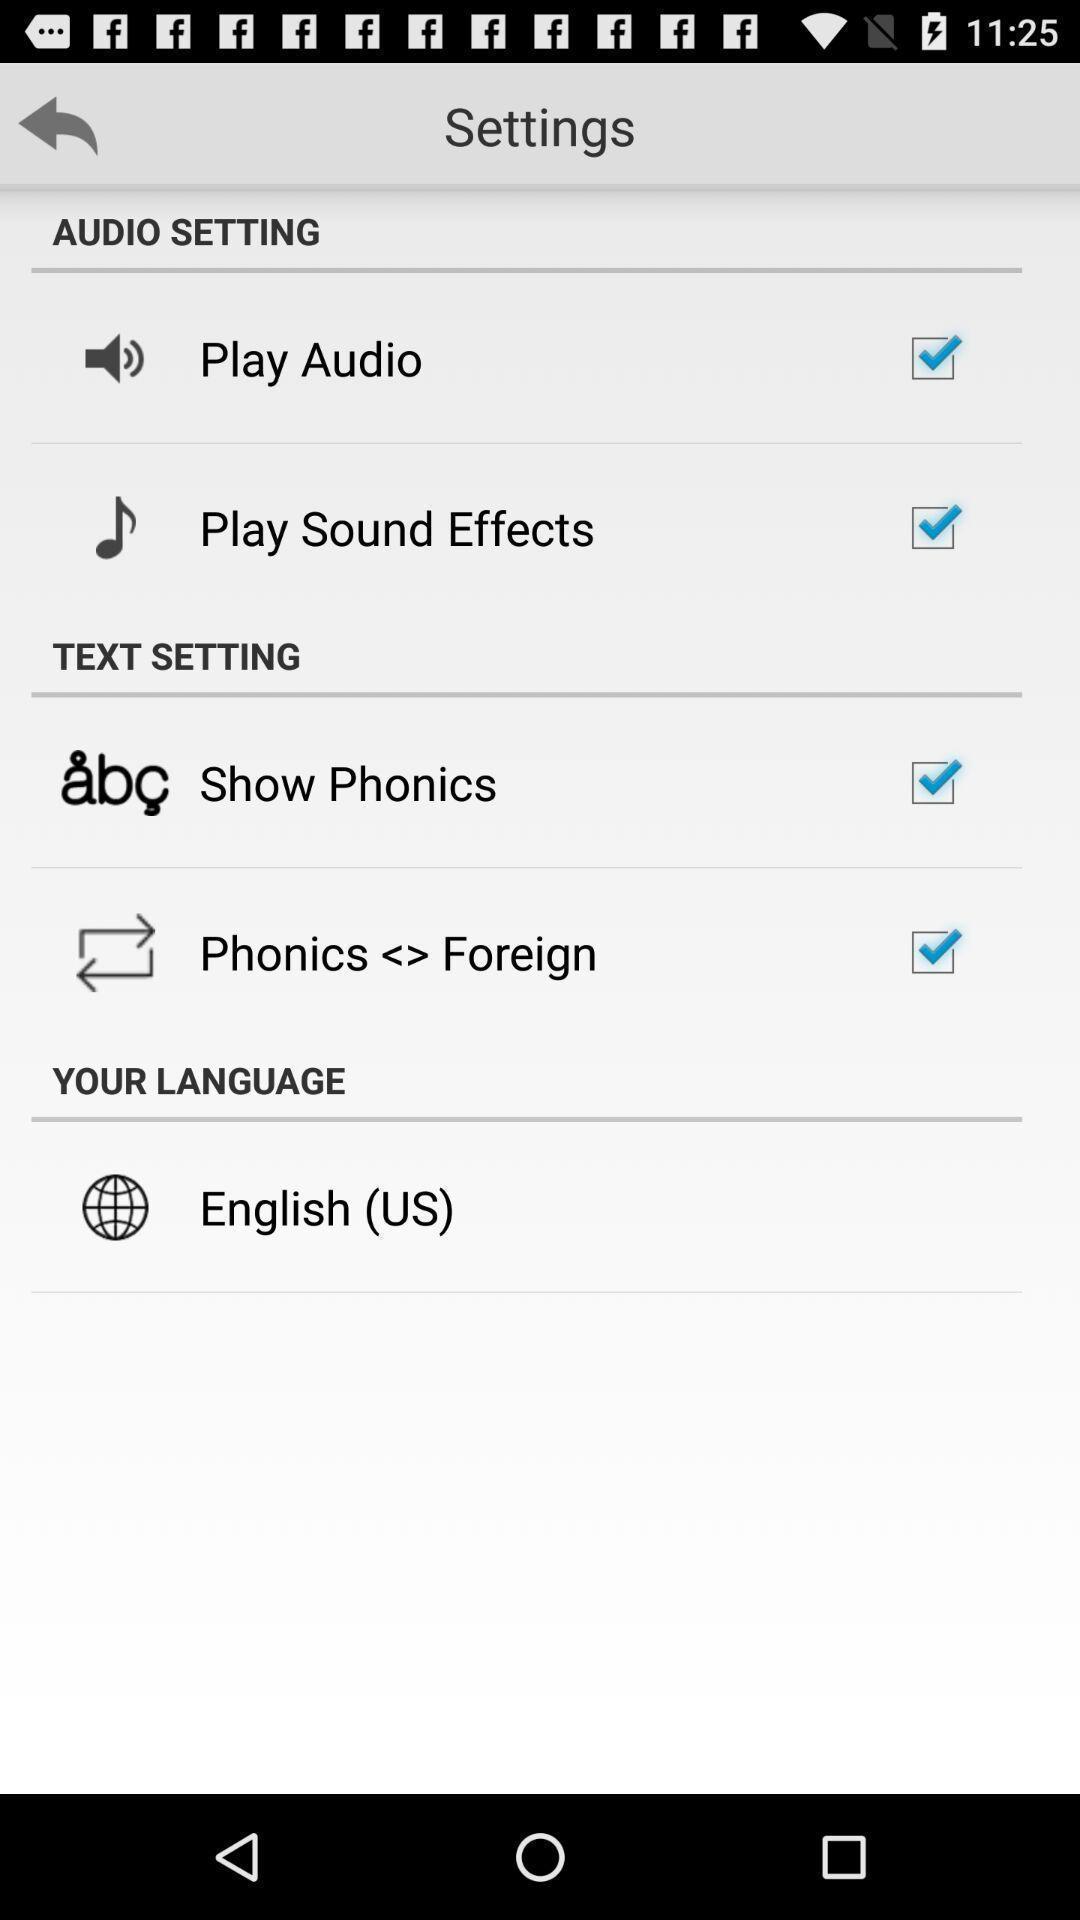Tell me what you see in this picture. Settings page with various other options social app. 